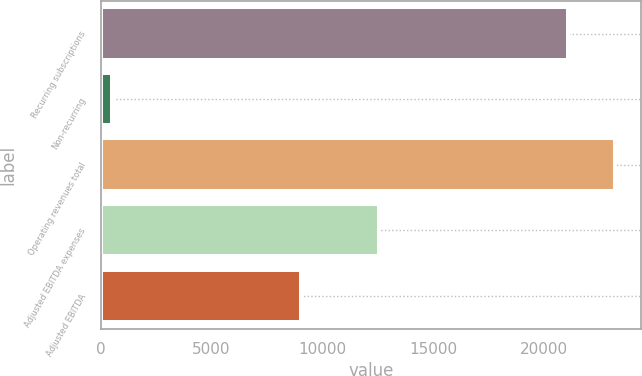Convert chart to OTSL. <chart><loc_0><loc_0><loc_500><loc_500><bar_chart><fcel>Recurring subscriptions<fcel>Non-recurring<fcel>Operating revenues total<fcel>Adjusted EBITDA expenses<fcel>Adjusted EBITDA<nl><fcel>21109<fcel>517<fcel>23219.9<fcel>12583<fcel>9043<nl></chart> 